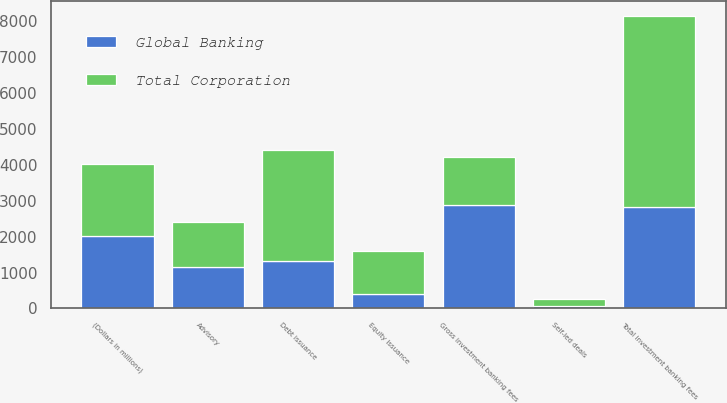Convert chart. <chart><loc_0><loc_0><loc_500><loc_500><stacked_bar_chart><ecel><fcel>(Dollars in millions)<fcel>Advisory<fcel>Debt issuance<fcel>Equity issuance<fcel>Gross investment banking fees<fcel>Self-led deals<fcel>Total investment banking fees<nl><fcel>Global Banking<fcel>2018<fcel>1152<fcel>1327<fcel>412<fcel>2891<fcel>68<fcel>2823<nl><fcel>Total Corporation<fcel>2018<fcel>1258<fcel>3084<fcel>1183<fcel>1327<fcel>198<fcel>5327<nl></chart> 